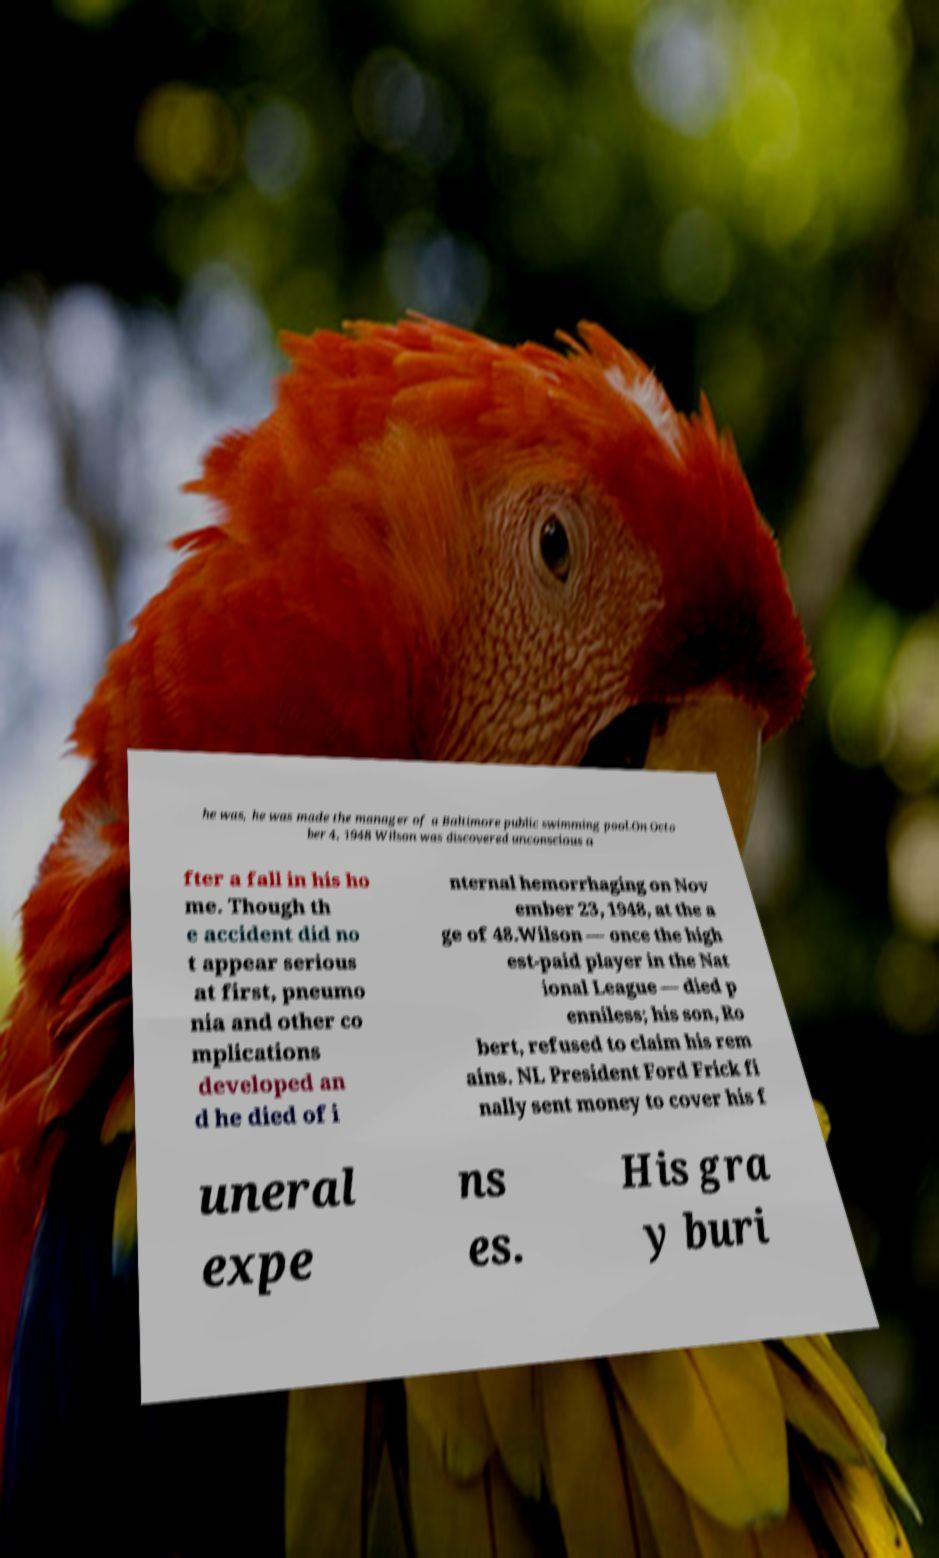Could you assist in decoding the text presented in this image and type it out clearly? he was, he was made the manager of a Baltimore public swimming pool.On Octo ber 4, 1948 Wilson was discovered unconscious a fter a fall in his ho me. Though th e accident did no t appear serious at first, pneumo nia and other co mplications developed an d he died of i nternal hemorrhaging on Nov ember 23, 1948, at the a ge of 48.Wilson — once the high est-paid player in the Nat ional League — died p enniless; his son, Ro bert, refused to claim his rem ains. NL President Ford Frick fi nally sent money to cover his f uneral expe ns es. His gra y buri 